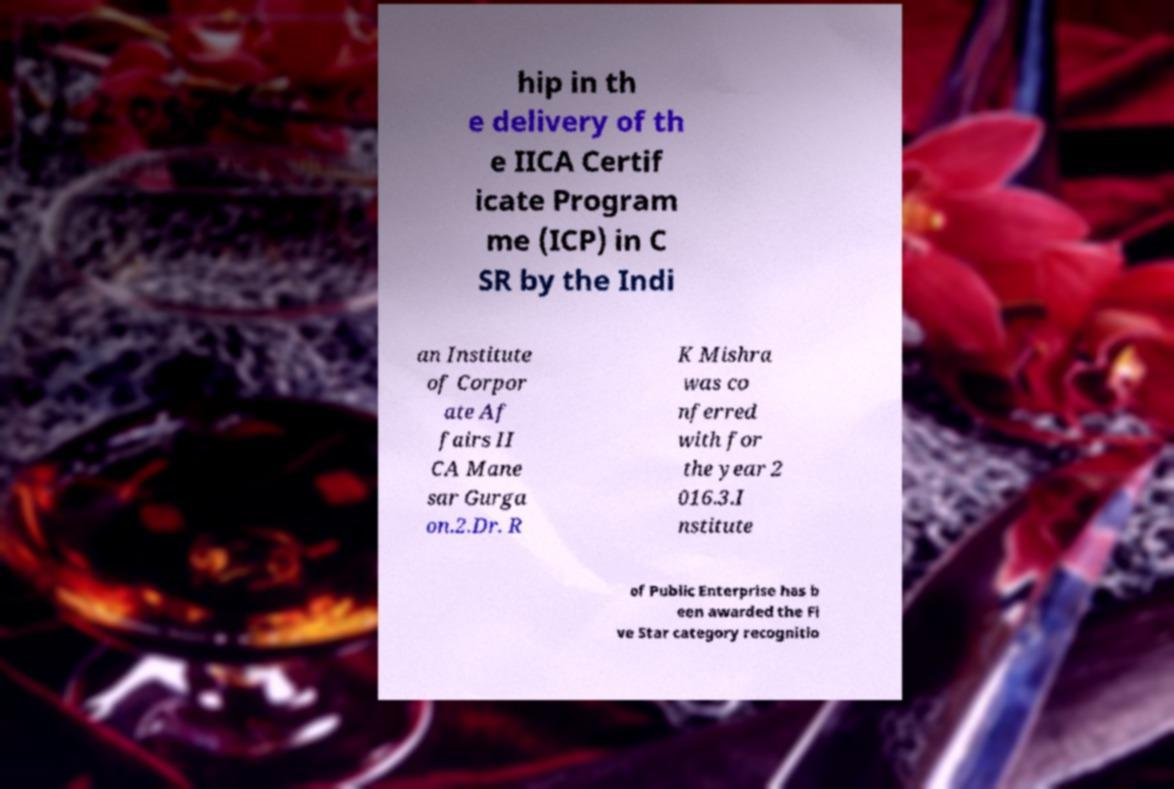Please identify and transcribe the text found in this image. hip in th e delivery of th e IICA Certif icate Program me (ICP) in C SR by the Indi an Institute of Corpor ate Af fairs II CA Mane sar Gurga on.2.Dr. R K Mishra was co nferred with for the year 2 016.3.I nstitute of Public Enterprise has b een awarded the Fi ve Star category recognitio 